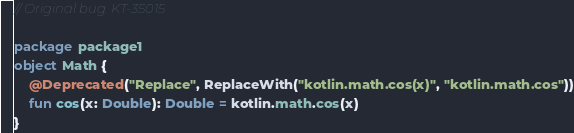<code> <loc_0><loc_0><loc_500><loc_500><_Kotlin_>// Original bug: KT-35015

package package1
object Math {
    @Deprecated("Replace", ReplaceWith("kotlin.math.cos(x)", "kotlin.math.cos"))
    fun cos(x: Double): Double = kotlin.math.cos(x)
}
</code> 